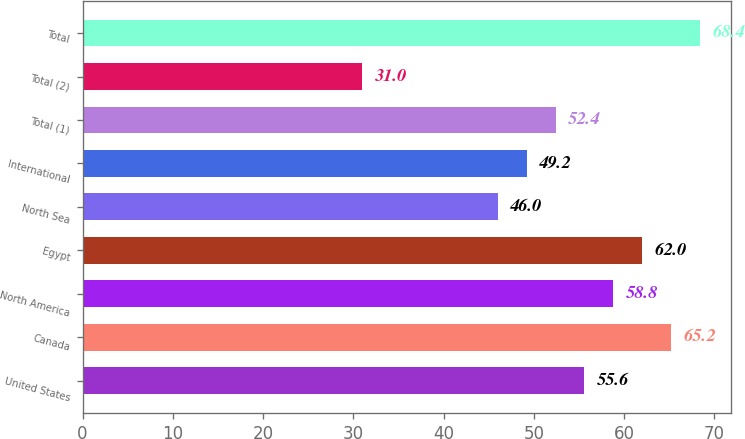Convert chart to OTSL. <chart><loc_0><loc_0><loc_500><loc_500><bar_chart><fcel>United States<fcel>Canada<fcel>North America<fcel>Egypt<fcel>North Sea<fcel>International<fcel>Total (1)<fcel>Total (2)<fcel>Total<nl><fcel>55.6<fcel>65.2<fcel>58.8<fcel>62<fcel>46<fcel>49.2<fcel>52.4<fcel>31<fcel>68.4<nl></chart> 